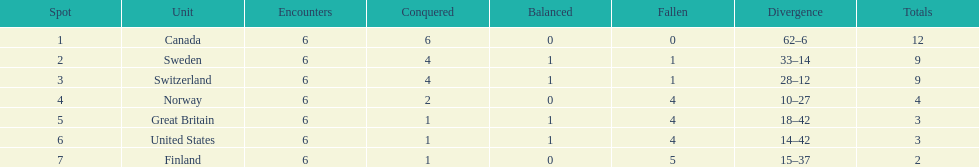What is the total number of teams to have 4 total wins? 2. 